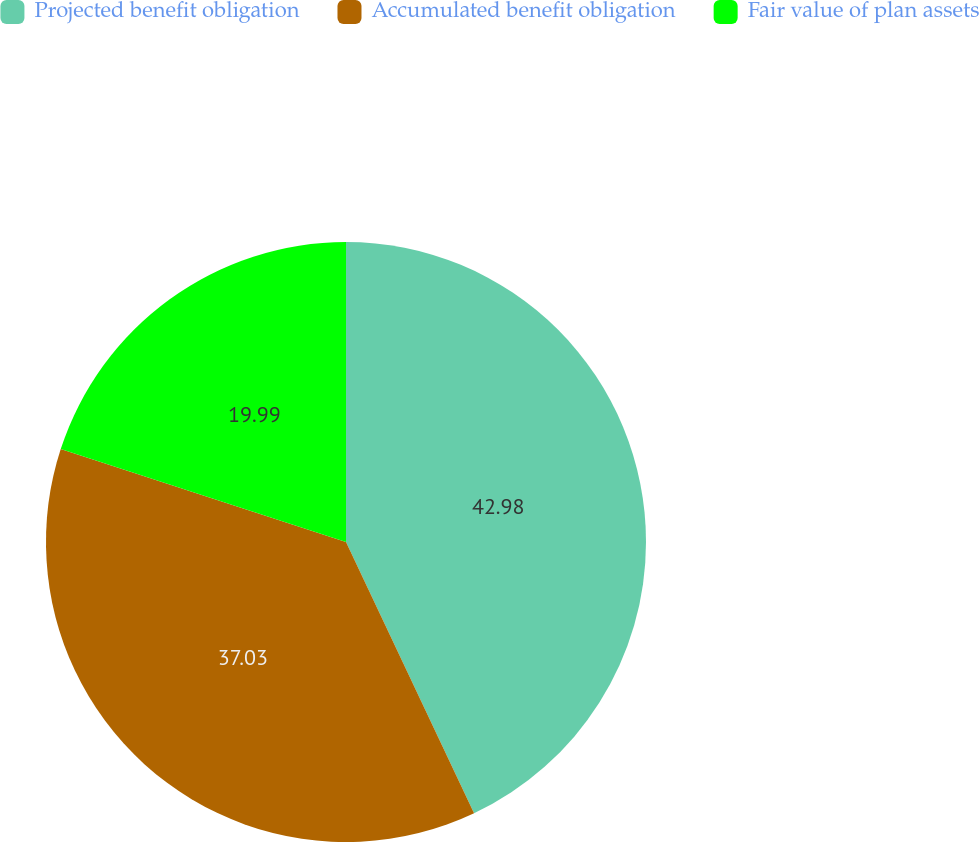<chart> <loc_0><loc_0><loc_500><loc_500><pie_chart><fcel>Projected benefit obligation<fcel>Accumulated benefit obligation<fcel>Fair value of plan assets<nl><fcel>42.98%<fcel>37.03%<fcel>19.99%<nl></chart> 